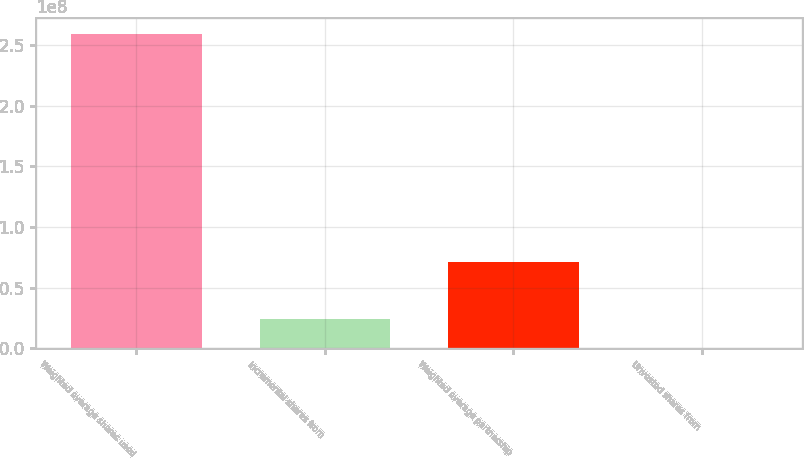Convert chart. <chart><loc_0><loc_0><loc_500><loc_500><bar_chart><fcel>Weighted average shares used<fcel>Incremental shares from<fcel>Weighted average partnership<fcel>Unvested shares from<nl><fcel>2.59378e+08<fcel>2.37163e+07<fcel>7.09368e+07<fcel>106103<nl></chart> 